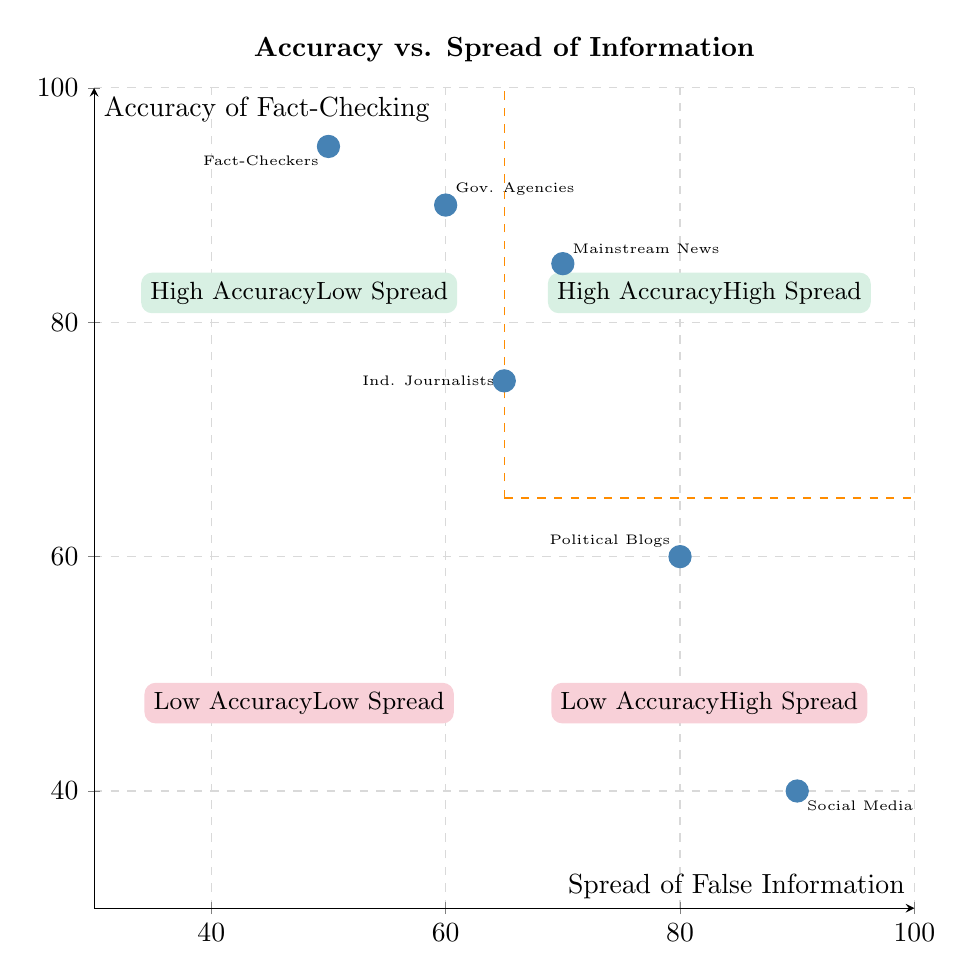What is the accuracy of Official Fact-Checkers? The accuracy of Official Fact-Checkers is represented on the Y-axis of the chart at a value of 95. This can be confirmed by locating the Official Fact-Checkers point marked on the chart.
Answer: 95 What is the spread of Social Media Platforms? The spread of Social Media Platforms is indicated on the X-axis of the chart at a value of 90. This is found by looking at the coordinates of the Social Media point on the chart.
Answer: 90 How many elements are in the diagram? There are six elements plotted on the chart: Mainstream News Outlets, Official Fact-Checkers, Social Media Platforms, Political Blogs, Government Agencies, and Independent Journalists. Counting these gives the total.
Answer: 6 Which entity has the highest spread of false information? By comparing the spread values of all entities on the X-axis, Social Media Platforms have the highest spread at 90. This is determined by finding the maximum X-coordinate among the points.
Answer: Social Media Platforms Which entities fall into the "High Accuracy Low Spread" quadrant? The quadrant labeled "High Accuracy Low Spread" includes Official Fact-Checkers and Government Agencies, as both have high accuracy scores and lower spread values according to the layout of the chart.
Answer: Official Fact-Checkers, Government Agencies What is the accuracy of Political Blogs? The accuracy of Political Blogs is marked on the Y-axis at a value of 60, which is verified by locating the coordinates of Political Blogs in the chart.
Answer: 60 How does the accuracy of Independent Journalists compare to Mainstream News Outlets? Independent Journalists have an accuracy of 75, while Mainstream News Outlets have an accuracy of 85. This indicates that Mainstream News Outlets have higher accuracy than Independent Journalists.
Answer: Mainstream News Outlets have higher accuracy Which quadrant has the lowest overall accuracy? The quadrant categorized as "Low Accuracy Low Spread" represents the lowest overall accuracy. No element is distinctly plotted there, as this quadrant is largely unoccupied in the data.
Answer: Low Accuracy Low Spread Which two entities have similar accuracy levels? Independent Journalists (75) and Political Blogs (60) are close in accuracy, though not identical, and they can be visually compared on the chart for their proximity.
Answer: Independent Journalists and Political Blogs 